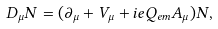<formula> <loc_0><loc_0><loc_500><loc_500>D _ { \mu } N = ( \partial _ { \mu } + V _ { \mu } + i e Q _ { e m } A _ { \mu } ) N ,</formula> 